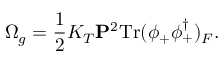<formula> <loc_0><loc_0><loc_500><loc_500>\Omega _ { g } = \frac { 1 } { 2 } K _ { T } { P } ^ { 2 } T r ( \phi _ { + } \phi _ { + } ^ { \dagger } ) _ { F } .</formula> 